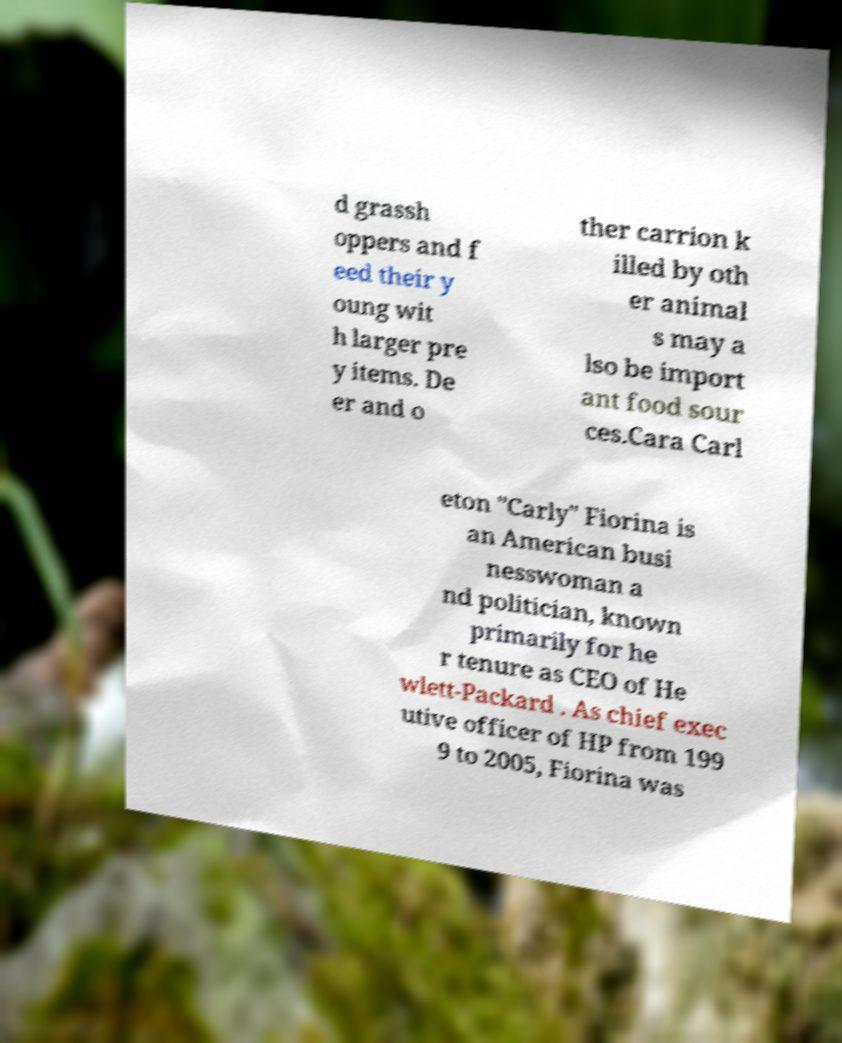Could you assist in decoding the text presented in this image and type it out clearly? d grassh oppers and f eed their y oung wit h larger pre y items. De er and o ther carrion k illed by oth er animal s may a lso be import ant food sour ces.Cara Carl eton "Carly" Fiorina is an American busi nesswoman a nd politician, known primarily for he r tenure as CEO of He wlett-Packard . As chief exec utive officer of HP from 199 9 to 2005, Fiorina was 